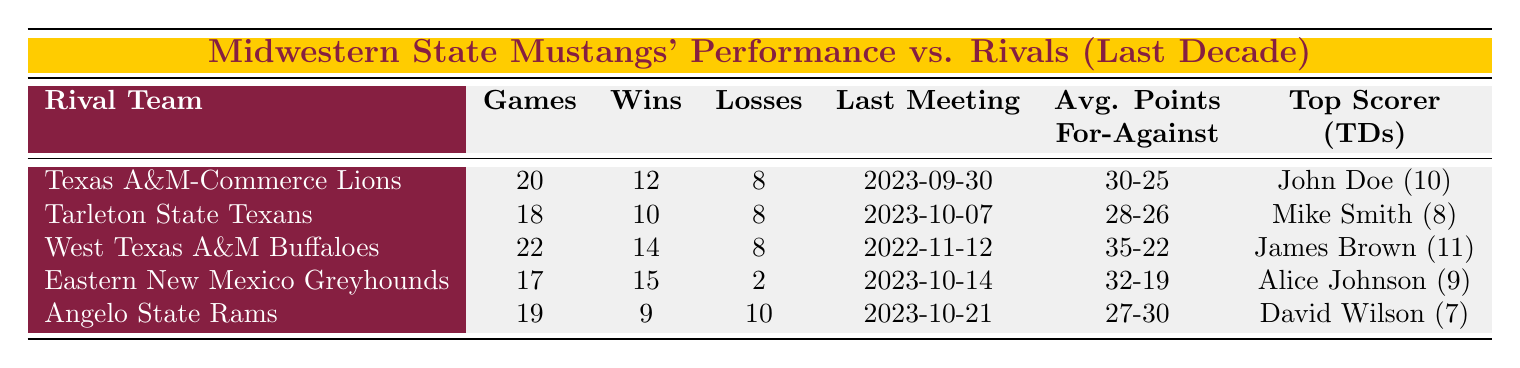What is the win-loss record for the Midwestern State Mustangs against Texas A&M-Commerce Lions? The win-loss record is found by looking at the corresponding row for Texas A&M-Commerce Lions, where it shows 12 wins and 8 losses.
Answer: 12 wins, 8 losses Which rival team has the highest average points scored against the Mustangs? By examining each rival team's average points scored, the highest is from the West Texas A&M Buffaloes, with an average of 35 points scored per game.
Answer: West Texas A&M Buffaloes How many games did the Mustangs play against Eastern New Mexico Greyhounds, and what was their performance? For Eastern New Mexico Greyhounds, the table lists that 17 games were played, with the Mustangs winning 15 of them and losing only 2, showing a strong performance against this rival team.
Answer: 17 games, 15 wins, 2 losses What is the difference in games played between the Mustangs and Tarleton State Texans? The Mustangs played 18 games against Tarleton State Texans, so we take the total games for Texas A&M-Commerce Lions (20) minus the games for Tarleton State Texans (18), which gives a difference of 2 games played.
Answer: 2 games Is it true that the Mustangs have won more games against Eastern New Mexico Greyhounds than they have against Angelo State Rams? Yes, the Mustangs have won 15 games against Eastern New Mexico Greyhounds and 9 games against Angelo State Rams, indicating they have won more against the Greyhounds.
Answer: Yes Which key player scored the most touchdowns against the Texas A&M-Commerce Lions, and how many were scored? Referring to the Texas A&M-Commerce Lions section, the key player listed is John Doe, who scored 10 touchdowns, highlighting his significant contribution in that matchup.
Answer: John Doe, 10 touchdowns What is the average points allowed by the Mustangs against the Tarleton State Texans? Checking the Tarleton State Texans row shows the Mustangs allowed an average of 26 points scored against them in those games, indicating their defensive performance in that matchup.
Answer: 26 points allowed How does the average points scored against the Mustangs compare between Angelo State Rams and Eastern New Mexico Greyhounds? The average points allowed is 30 for Angelo State Rams and 19 for Eastern New Mexico Greyhounds. Thus, the Mustangs allowed significantly more points against Angelo State Rams than against Eastern New Mexico Greyhounds.
Answer: Angelo State Rams: 30, Eastern New Mexico Greyhounds: 19 Who is the top scorer for the West Texas A&M Buffaloes and how many touchdowns did they score? The table indicates that James Brown is the top scorer for West Texas A&M Buffaloes with 11 touchdowns, showcasing his impactful performance against the Mustangs.
Answer: James Brown, 11 touchdowns 